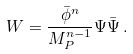Convert formula to latex. <formula><loc_0><loc_0><loc_500><loc_500>W = \frac { \bar { \phi } ^ { n } } { M _ { P } ^ { n - 1 } } \Psi \bar { \Psi } \, .</formula> 